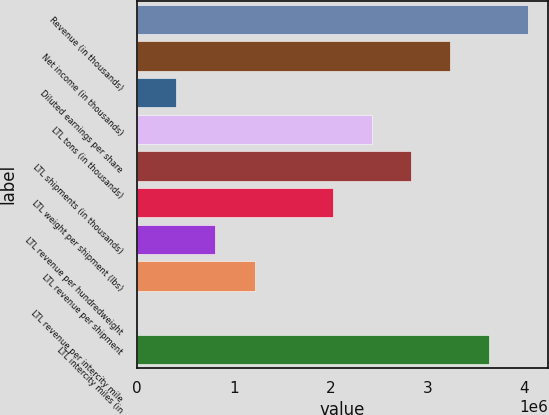<chart> <loc_0><loc_0><loc_500><loc_500><bar_chart><fcel>Revenue (in thousands)<fcel>Net income (in thousands)<fcel>Diluted earnings per share<fcel>LTL tons (in thousands)<fcel>LTL shipments (in thousands)<fcel>LTL weight per shipment (lbs)<fcel>LTL revenue per hundredweight<fcel>LTL revenue per shipment<fcel>LTL revenue per intercity mile<fcel>LTL intercity miles (in<nl><fcel>4.0437e+06<fcel>3.23496e+06<fcel>404375<fcel>2.42622e+06<fcel>2.83059e+06<fcel>2.02185e+06<fcel>808744<fcel>1.21311e+06<fcel>5.91<fcel>3.63933e+06<nl></chart> 